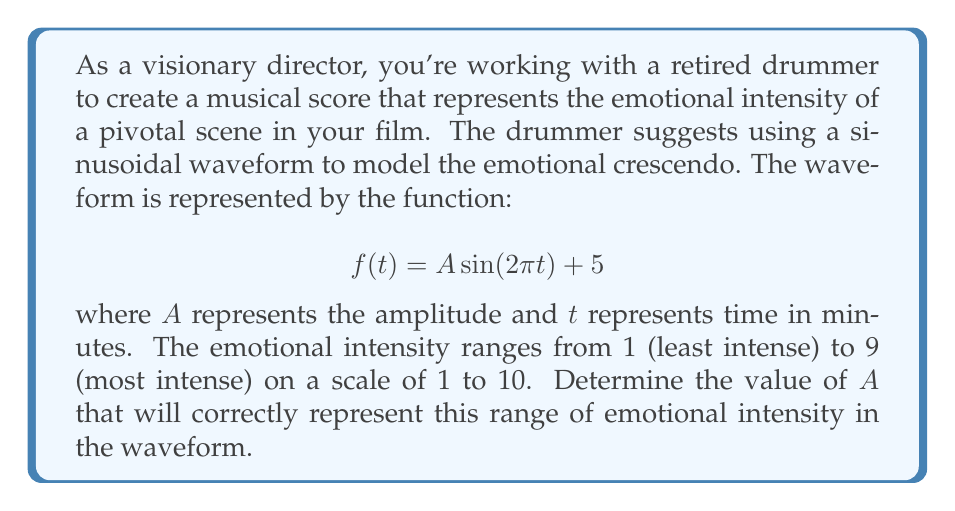Could you help me with this problem? To solve this problem, we need to follow these steps:

1) First, recall that the amplitude of a sine function is half the distance between its maximum and minimum values.

2) In the given function $f(t) = A \sin(2\pi t) + 5$, the sine term oscillates between -1 and 1, so the function will oscillate between $5-A$ and $5+A$.

3) We want the minimum value to represent the least intense emotion (1) and the maximum value to represent the most intense emotion (9):

   Minimum: $5 - A = 1$
   Maximum: $5 + A = 9$

4) We can solve either equation for $A$. Let's use the first one:

   $5 - A = 1$
   $-A = -4$
   $A = 4$

5) We can verify this with the second equation:

   $5 + A = 5 + 4 = 9$

6) Therefore, an amplitude of 4 will create a waveform that oscillates between 1 and 9, correctly representing the desired range of emotional intensity.
Answer: $A = 4$ 